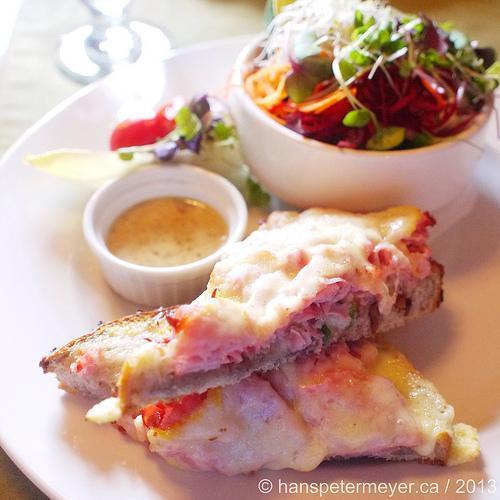How many sandwich halves are there?
Give a very brief answer. 2. 